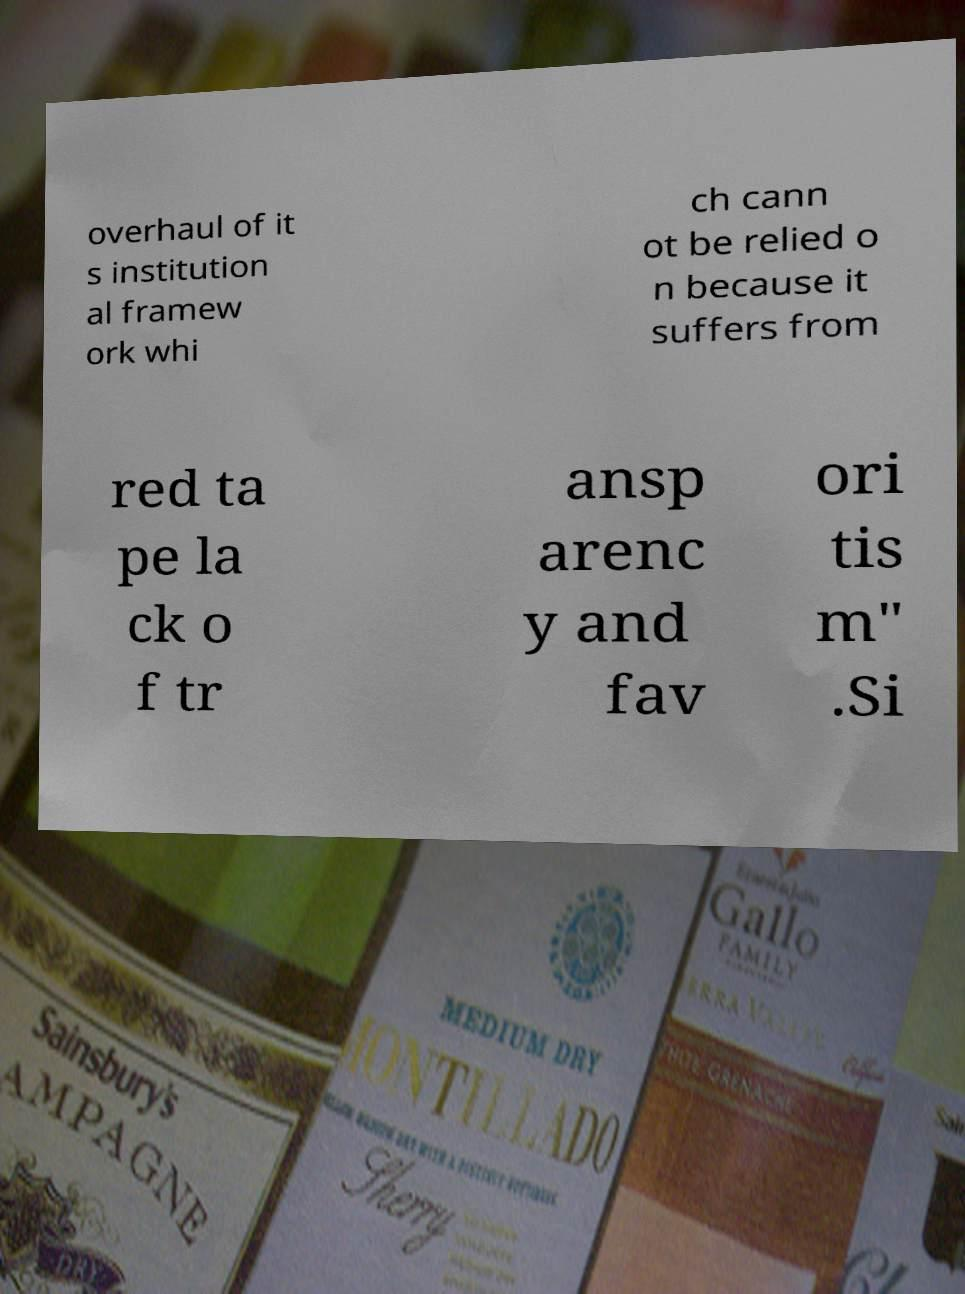Can you accurately transcribe the text from the provided image for me? overhaul of it s institution al framew ork whi ch cann ot be relied o n because it suffers from red ta pe la ck o f tr ansp arenc y and fav ori tis m" .Si 